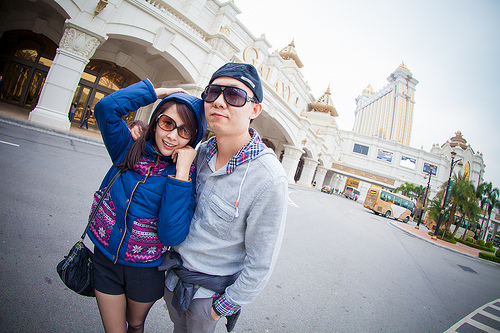<image>
Can you confirm if the bus is to the right of the girl? Yes. From this viewpoint, the bus is positioned to the right side relative to the girl. 